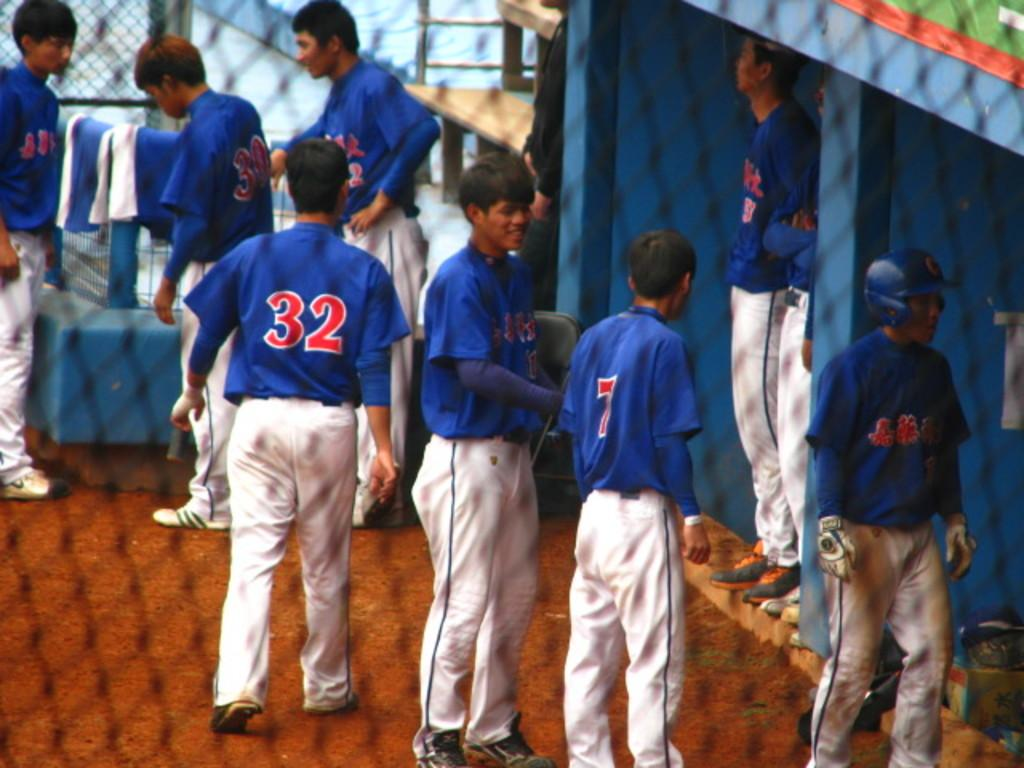Provide a one-sentence caption for the provided image. a baseball team with one of the players wearing number 32. 